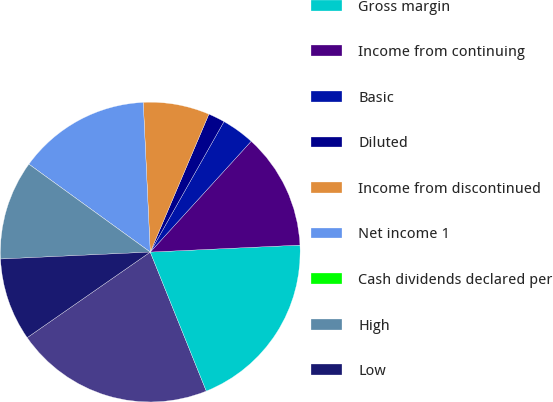<chart> <loc_0><loc_0><loc_500><loc_500><pie_chart><fcel>Net sales<fcel>Gross margin<fcel>Income from continuing<fcel>Basic<fcel>Diluted<fcel>Income from discontinued<fcel>Net income 1<fcel>Cash dividends declared per<fcel>High<fcel>Low<nl><fcel>21.43%<fcel>19.64%<fcel>12.5%<fcel>3.57%<fcel>1.79%<fcel>7.14%<fcel>14.28%<fcel>0.0%<fcel>10.71%<fcel>8.93%<nl></chart> 